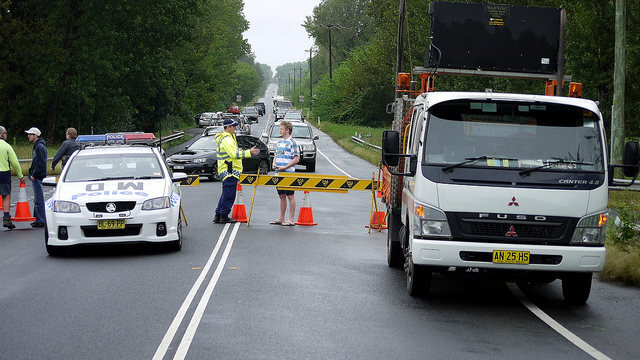Identify the text displayed in this image. BE PP police W AN 25 HS 